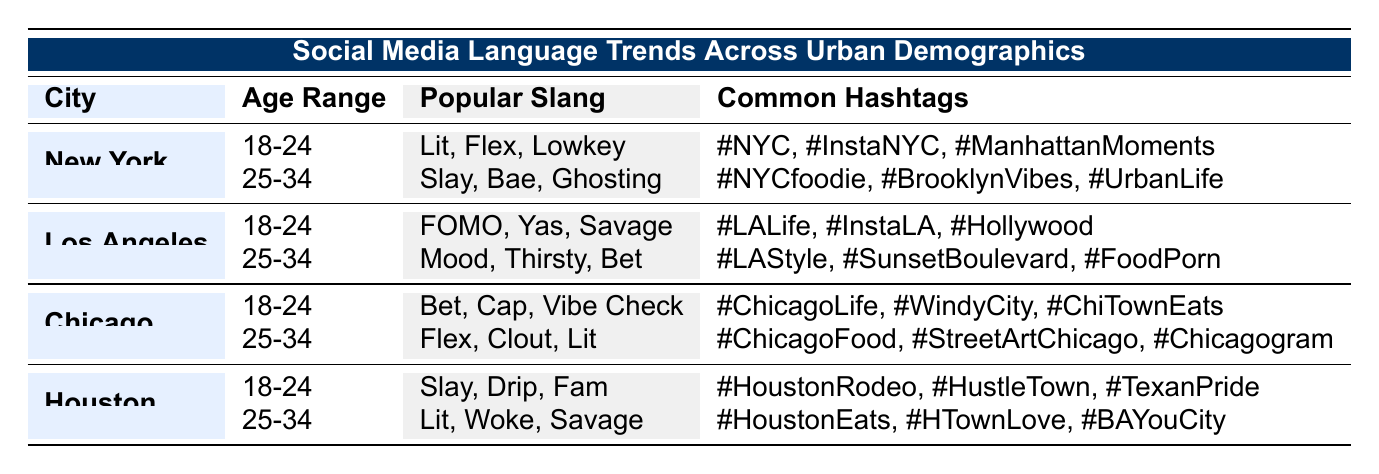What are the popular slangs used by 18-24 year olds in New York? The table shows that the popular slangs for the 18-24 age group in New York are "Lit," "Flex," and "Lowkey."
Answer: Lit, Flex, Lowkey In which city do 25-34 year olds use the slang "Bet"? According to the table, the slang "Bet" is used by the 25-34 age group in Los Angeles and Chicago.
Answer: Chicago What is the common hashtag for 18-24 year olds in Houston? The table indicates that the common hashtags for the 18-24 age group in Houston are "#HoustonRodeo," "#HustleTown," and "#TexanPride."
Answer: #HoustonRodeo, #HustleTown, #TexanPride Which age group spends the most time online in New York? The 18-24 age group spends 3.5 hours a day online, which is more than the 25-34 age group that spends 2.5 hours a day.
Answer: 18-24 Is "Savage" a popular slang for the 25-34 year olds in Houston? Yes, the table lists "Savage" as one of the popular slangs for the 25-34 age group in Houston.
Answer: Yes Compare the average time spent online by both age groups in Los Angeles. In Los Angeles, there's no specific time value provided for the 18-24 and 25-34 age groups, making it impossible to calculate an average. The question cannot be answered based on the table alone.
Answer: N/A What is the total number of unique popular slangs listed across all cities for the age range 25-34? The popular slangs for each city in the 25-34 age group are Slay, Bae, Ghosting, Mood, Thirsty, Bet, Flex, Clout, Lit, and Woke, totaling ten unique slangs.
Answer: 10 Does the slang "Lit" appear in more than one age group in the table? Yes, "Lit" is listed as a popular slang for both the 18-24 and 25-34 age groups in New York and Houston.
Answer: Yes What is the most popular hashtag for 25-34 year olds in Chicago? The most popular hashtags for the 25-34 age group in Chicago are "#ChicagoFood," "#StreetArtChicago," and "#Chicagogram."
Answer: #ChicagoFood, #StreetArtChicago, #Chicagogram 